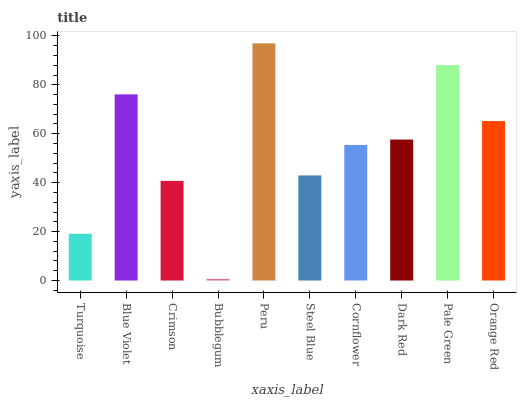Is Bubblegum the minimum?
Answer yes or no. Yes. Is Peru the maximum?
Answer yes or no. Yes. Is Blue Violet the minimum?
Answer yes or no. No. Is Blue Violet the maximum?
Answer yes or no. No. Is Blue Violet greater than Turquoise?
Answer yes or no. Yes. Is Turquoise less than Blue Violet?
Answer yes or no. Yes. Is Turquoise greater than Blue Violet?
Answer yes or no. No. Is Blue Violet less than Turquoise?
Answer yes or no. No. Is Dark Red the high median?
Answer yes or no. Yes. Is Cornflower the low median?
Answer yes or no. Yes. Is Pale Green the high median?
Answer yes or no. No. Is Steel Blue the low median?
Answer yes or no. No. 